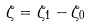<formula> <loc_0><loc_0><loc_500><loc_500>\zeta = \zeta _ { 1 } - \zeta _ { 0 }</formula> 